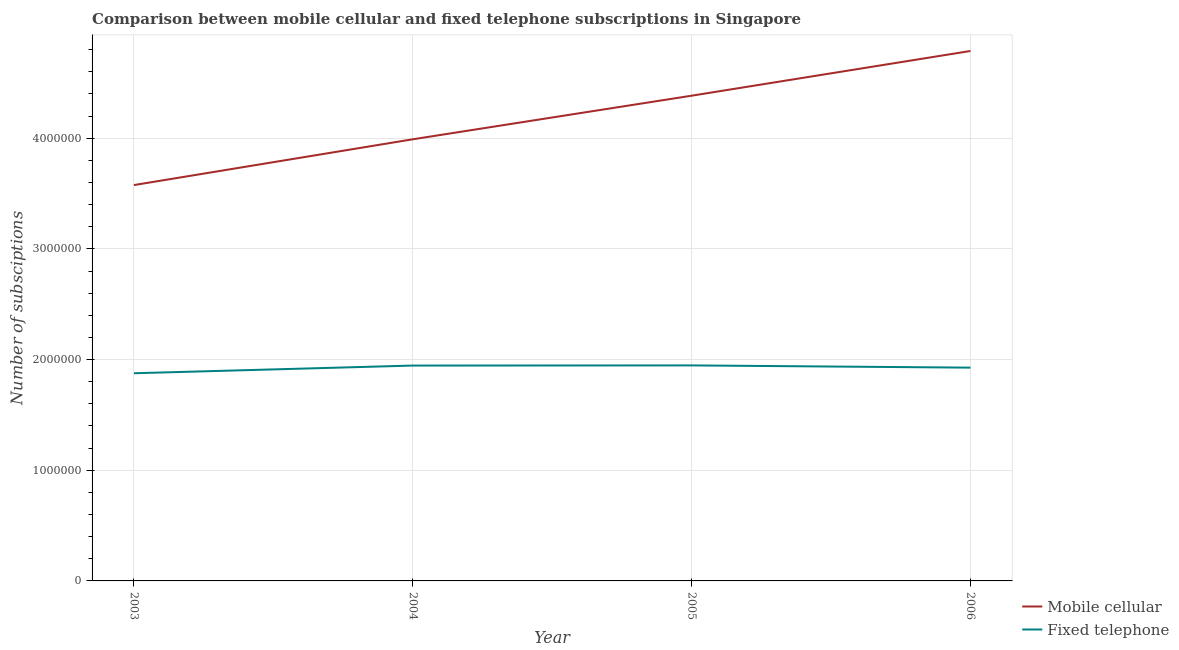How many different coloured lines are there?
Provide a succinct answer. 2. What is the number of mobile cellular subscriptions in 2005?
Give a very brief answer. 4.38e+06. Across all years, what is the maximum number of fixed telephone subscriptions?
Provide a short and direct response. 1.95e+06. Across all years, what is the minimum number of fixed telephone subscriptions?
Provide a short and direct response. 1.88e+06. In which year was the number of fixed telephone subscriptions minimum?
Provide a succinct answer. 2003. What is the total number of mobile cellular subscriptions in the graph?
Give a very brief answer. 1.67e+07. What is the difference between the number of fixed telephone subscriptions in 2005 and that in 2006?
Give a very brief answer. 2.03e+04. What is the difference between the number of fixed telephone subscriptions in 2004 and the number of mobile cellular subscriptions in 2006?
Offer a very short reply. -2.84e+06. What is the average number of mobile cellular subscriptions per year?
Ensure brevity in your answer.  4.19e+06. In the year 2004, what is the difference between the number of mobile cellular subscriptions and number of fixed telephone subscriptions?
Provide a succinct answer. 2.04e+06. What is the ratio of the number of mobile cellular subscriptions in 2003 to that in 2004?
Your response must be concise. 0.9. What is the difference between the highest and the second highest number of mobile cellular subscriptions?
Give a very brief answer. 4.04e+05. What is the difference between the highest and the lowest number of mobile cellular subscriptions?
Offer a terse response. 1.21e+06. In how many years, is the number of mobile cellular subscriptions greater than the average number of mobile cellular subscriptions taken over all years?
Your answer should be very brief. 2. Is the sum of the number of fixed telephone subscriptions in 2004 and 2006 greater than the maximum number of mobile cellular subscriptions across all years?
Your answer should be compact. No. Is the number of mobile cellular subscriptions strictly less than the number of fixed telephone subscriptions over the years?
Offer a terse response. No. How many years are there in the graph?
Your answer should be very brief. 4. What is the difference between two consecutive major ticks on the Y-axis?
Your answer should be compact. 1.00e+06. Are the values on the major ticks of Y-axis written in scientific E-notation?
Ensure brevity in your answer.  No. Does the graph contain any zero values?
Provide a short and direct response. No. Does the graph contain grids?
Your answer should be compact. Yes. What is the title of the graph?
Ensure brevity in your answer.  Comparison between mobile cellular and fixed telephone subscriptions in Singapore. What is the label or title of the X-axis?
Make the answer very short. Year. What is the label or title of the Y-axis?
Provide a succinct answer. Number of subsciptions. What is the Number of subsciptions in Mobile cellular in 2003?
Give a very brief answer. 3.58e+06. What is the Number of subsciptions in Fixed telephone in 2003?
Offer a terse response. 1.88e+06. What is the Number of subsciptions in Mobile cellular in 2004?
Give a very brief answer. 3.99e+06. What is the Number of subsciptions in Fixed telephone in 2004?
Provide a short and direct response. 1.95e+06. What is the Number of subsciptions in Mobile cellular in 2005?
Your response must be concise. 4.38e+06. What is the Number of subsciptions of Fixed telephone in 2005?
Ensure brevity in your answer.  1.95e+06. What is the Number of subsciptions of Mobile cellular in 2006?
Provide a succinct answer. 4.79e+06. What is the Number of subsciptions in Fixed telephone in 2006?
Offer a terse response. 1.93e+06. Across all years, what is the maximum Number of subsciptions of Mobile cellular?
Offer a terse response. 4.79e+06. Across all years, what is the maximum Number of subsciptions of Fixed telephone?
Ensure brevity in your answer.  1.95e+06. Across all years, what is the minimum Number of subsciptions of Mobile cellular?
Give a very brief answer. 3.58e+06. Across all years, what is the minimum Number of subsciptions of Fixed telephone?
Your answer should be compact. 1.88e+06. What is the total Number of subsciptions in Mobile cellular in the graph?
Your response must be concise. 1.67e+07. What is the total Number of subsciptions of Fixed telephone in the graph?
Offer a very short reply. 7.70e+06. What is the difference between the Number of subsciptions in Mobile cellular in 2003 and that in 2004?
Provide a succinct answer. -4.14e+05. What is the difference between the Number of subsciptions of Fixed telephone in 2003 and that in 2004?
Ensure brevity in your answer.  -6.94e+04. What is the difference between the Number of subsciptions of Mobile cellular in 2003 and that in 2005?
Your response must be concise. -8.08e+05. What is the difference between the Number of subsciptions in Fixed telephone in 2003 and that in 2005?
Your answer should be very brief. -7.09e+04. What is the difference between the Number of subsciptions in Mobile cellular in 2003 and that in 2006?
Offer a very short reply. -1.21e+06. What is the difference between the Number of subsciptions of Fixed telephone in 2003 and that in 2006?
Give a very brief answer. -5.06e+04. What is the difference between the Number of subsciptions in Mobile cellular in 2004 and that in 2005?
Provide a succinct answer. -3.94e+05. What is the difference between the Number of subsciptions in Fixed telephone in 2004 and that in 2005?
Give a very brief answer. -1500. What is the difference between the Number of subsciptions of Mobile cellular in 2004 and that in 2006?
Offer a very short reply. -7.98e+05. What is the difference between the Number of subsciptions of Fixed telephone in 2004 and that in 2006?
Keep it short and to the point. 1.88e+04. What is the difference between the Number of subsciptions in Mobile cellular in 2005 and that in 2006?
Your answer should be compact. -4.04e+05. What is the difference between the Number of subsciptions of Fixed telephone in 2005 and that in 2006?
Ensure brevity in your answer.  2.03e+04. What is the difference between the Number of subsciptions in Mobile cellular in 2003 and the Number of subsciptions in Fixed telephone in 2004?
Ensure brevity in your answer.  1.63e+06. What is the difference between the Number of subsciptions of Mobile cellular in 2003 and the Number of subsciptions of Fixed telephone in 2005?
Ensure brevity in your answer.  1.63e+06. What is the difference between the Number of subsciptions in Mobile cellular in 2003 and the Number of subsciptions in Fixed telephone in 2006?
Your response must be concise. 1.65e+06. What is the difference between the Number of subsciptions in Mobile cellular in 2004 and the Number of subsciptions in Fixed telephone in 2005?
Give a very brief answer. 2.04e+06. What is the difference between the Number of subsciptions in Mobile cellular in 2004 and the Number of subsciptions in Fixed telephone in 2006?
Make the answer very short. 2.06e+06. What is the difference between the Number of subsciptions of Mobile cellular in 2005 and the Number of subsciptions of Fixed telephone in 2006?
Your answer should be very brief. 2.46e+06. What is the average Number of subsciptions in Mobile cellular per year?
Provide a succinct answer. 4.19e+06. What is the average Number of subsciptions in Fixed telephone per year?
Provide a succinct answer. 1.92e+06. In the year 2003, what is the difference between the Number of subsciptions in Mobile cellular and Number of subsciptions in Fixed telephone?
Your answer should be very brief. 1.70e+06. In the year 2004, what is the difference between the Number of subsciptions in Mobile cellular and Number of subsciptions in Fixed telephone?
Give a very brief answer. 2.04e+06. In the year 2005, what is the difference between the Number of subsciptions in Mobile cellular and Number of subsciptions in Fixed telephone?
Keep it short and to the point. 2.44e+06. In the year 2006, what is the difference between the Number of subsciptions in Mobile cellular and Number of subsciptions in Fixed telephone?
Ensure brevity in your answer.  2.86e+06. What is the ratio of the Number of subsciptions in Mobile cellular in 2003 to that in 2004?
Give a very brief answer. 0.9. What is the ratio of the Number of subsciptions in Mobile cellular in 2003 to that in 2005?
Provide a succinct answer. 0.82. What is the ratio of the Number of subsciptions of Fixed telephone in 2003 to that in 2005?
Offer a terse response. 0.96. What is the ratio of the Number of subsciptions of Mobile cellular in 2003 to that in 2006?
Offer a very short reply. 0.75. What is the ratio of the Number of subsciptions in Fixed telephone in 2003 to that in 2006?
Make the answer very short. 0.97. What is the ratio of the Number of subsciptions of Mobile cellular in 2004 to that in 2005?
Your answer should be compact. 0.91. What is the ratio of the Number of subsciptions in Fixed telephone in 2004 to that in 2005?
Provide a succinct answer. 1. What is the ratio of the Number of subsciptions of Mobile cellular in 2004 to that in 2006?
Your answer should be compact. 0.83. What is the ratio of the Number of subsciptions of Fixed telephone in 2004 to that in 2006?
Your response must be concise. 1.01. What is the ratio of the Number of subsciptions of Mobile cellular in 2005 to that in 2006?
Your response must be concise. 0.92. What is the ratio of the Number of subsciptions of Fixed telephone in 2005 to that in 2006?
Ensure brevity in your answer.  1.01. What is the difference between the highest and the second highest Number of subsciptions of Mobile cellular?
Provide a short and direct response. 4.04e+05. What is the difference between the highest and the second highest Number of subsciptions of Fixed telephone?
Provide a short and direct response. 1500. What is the difference between the highest and the lowest Number of subsciptions of Mobile cellular?
Offer a terse response. 1.21e+06. What is the difference between the highest and the lowest Number of subsciptions of Fixed telephone?
Your answer should be very brief. 7.09e+04. 